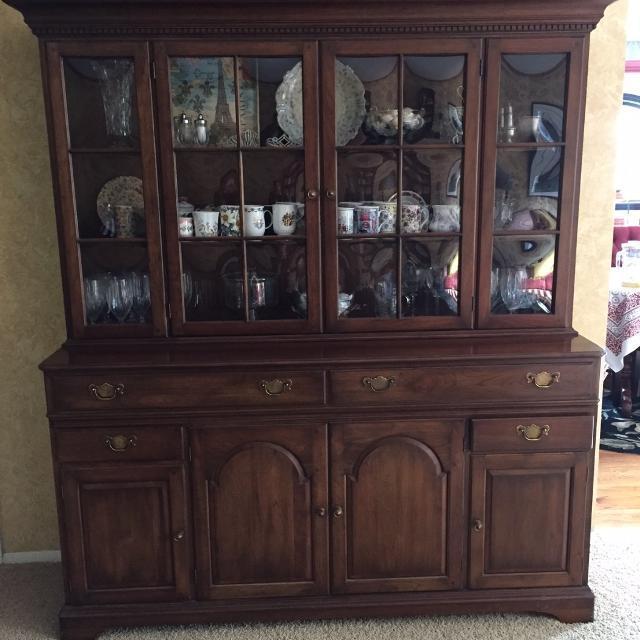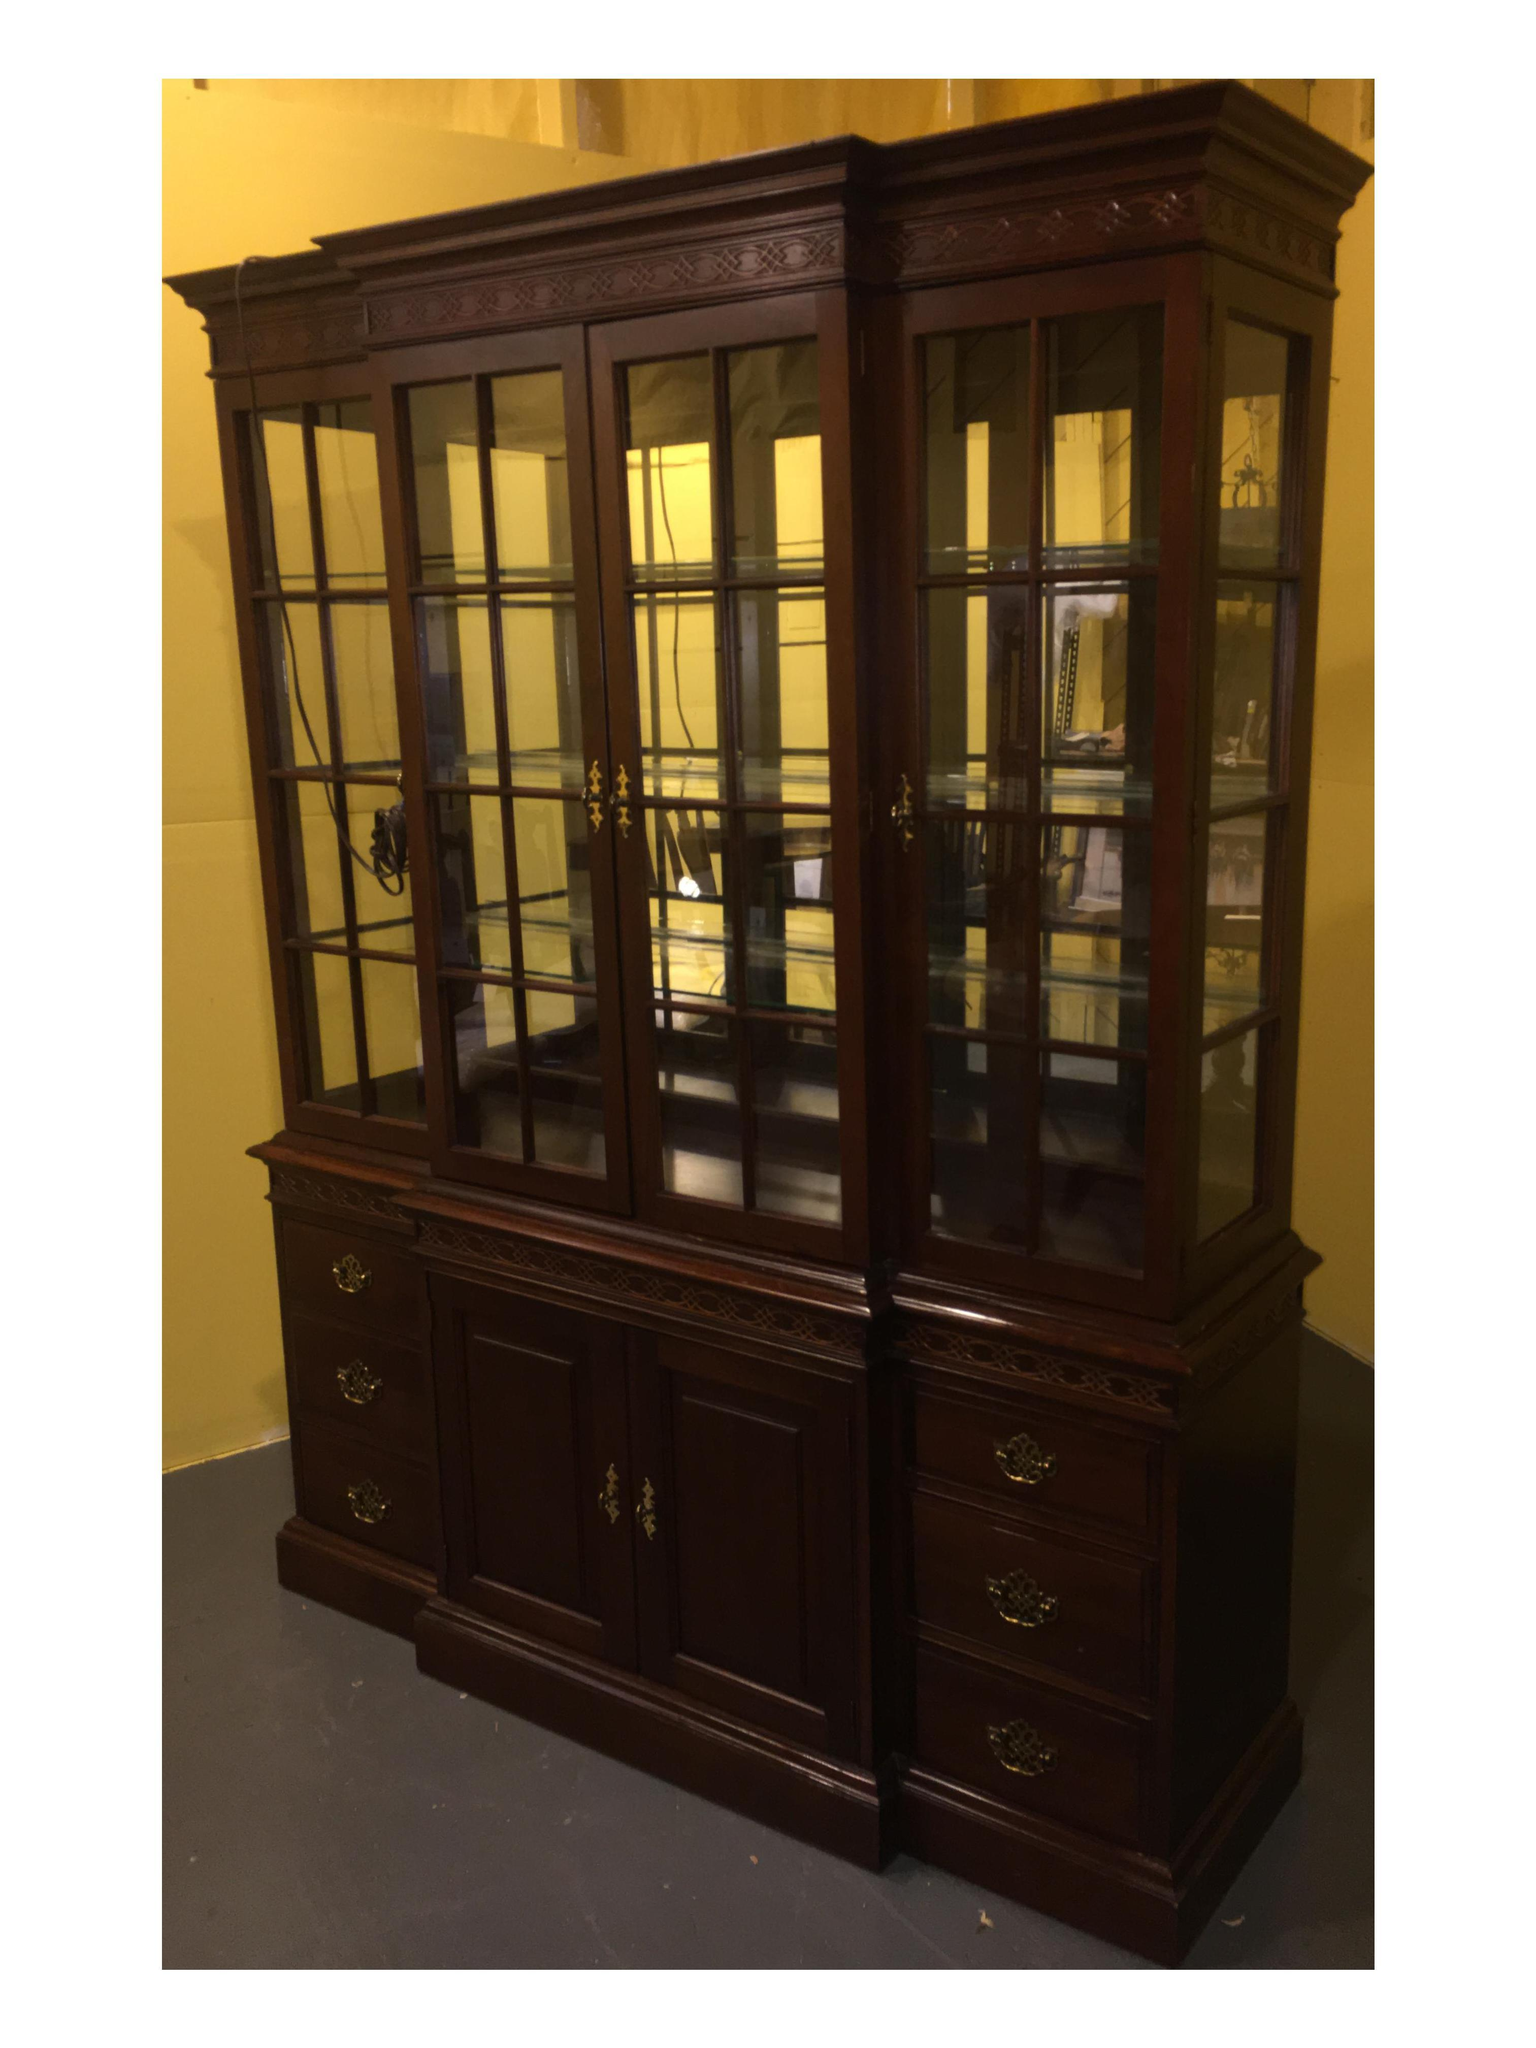The first image is the image on the left, the second image is the image on the right. Examine the images to the left and right. Is the description "The shelves on the left are full." accurate? Answer yes or no. Yes. 